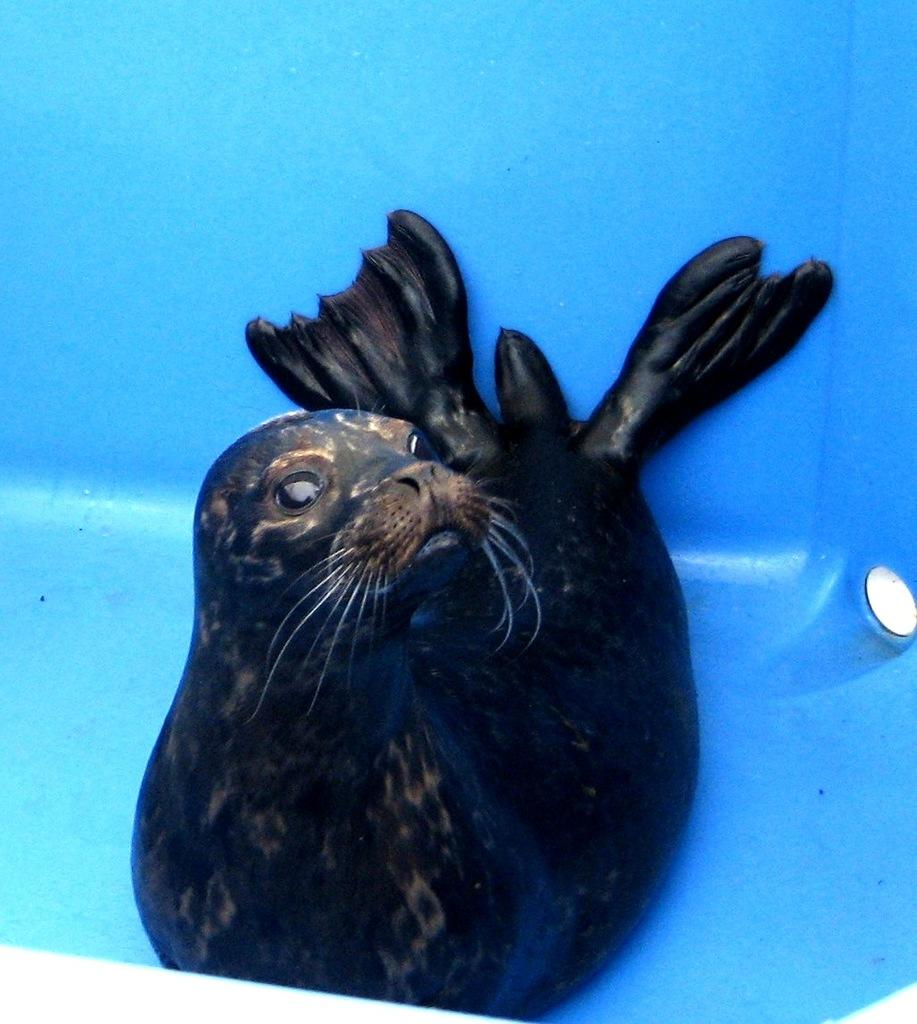What type of animal is in the image? There is a sea lion in the image. What type of spark can be seen coming from the sea lion's nose in the image? There is no spark coming from the sea lion's nose in the image. What committee is responsible for the sea lion's well-being in the image? There is no committee mentioned or implied in the image. 